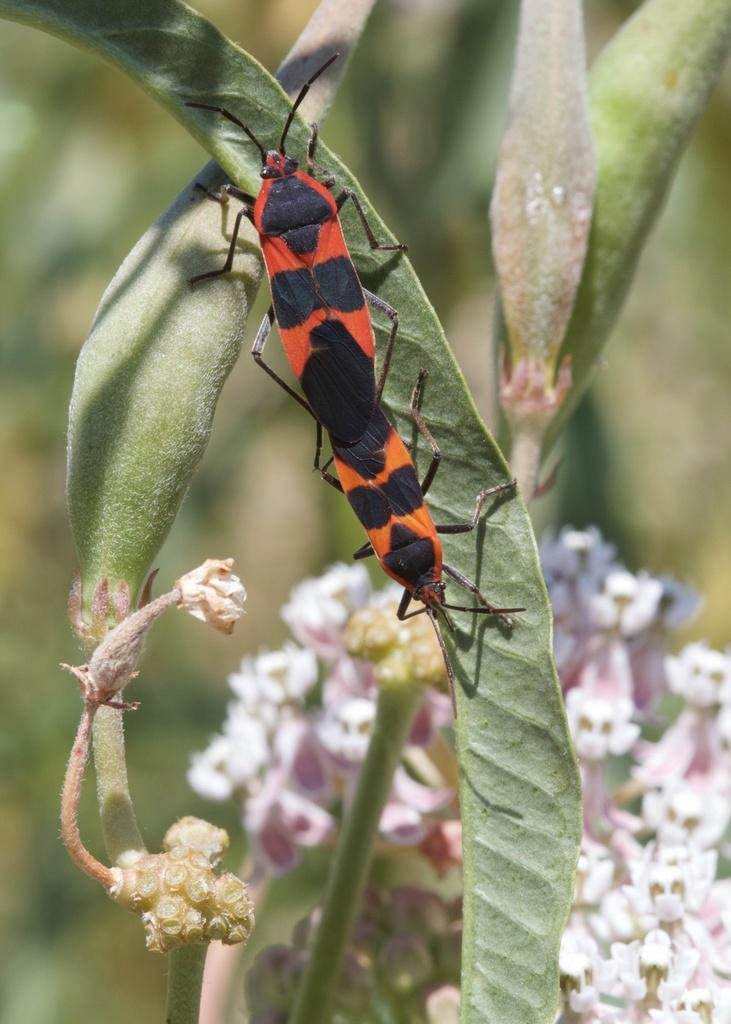What is present on the leaf in the image? There are insects on a leaf in the image. What can be seen on the plant in the image? There are flowers on a plant in the image. What color are the flowers on the plant? The flowers on the plant are white in the image. How would you describe the clarity of the image? The image is blurry. What type of book is the person reading in the image? There is no person reading a book in the image; it features insects on a leaf and flowers on a plant. What is the weather like in the image? The weather cannot be determined from the image, as it only shows insects on a leaf and flowers on a plant. 